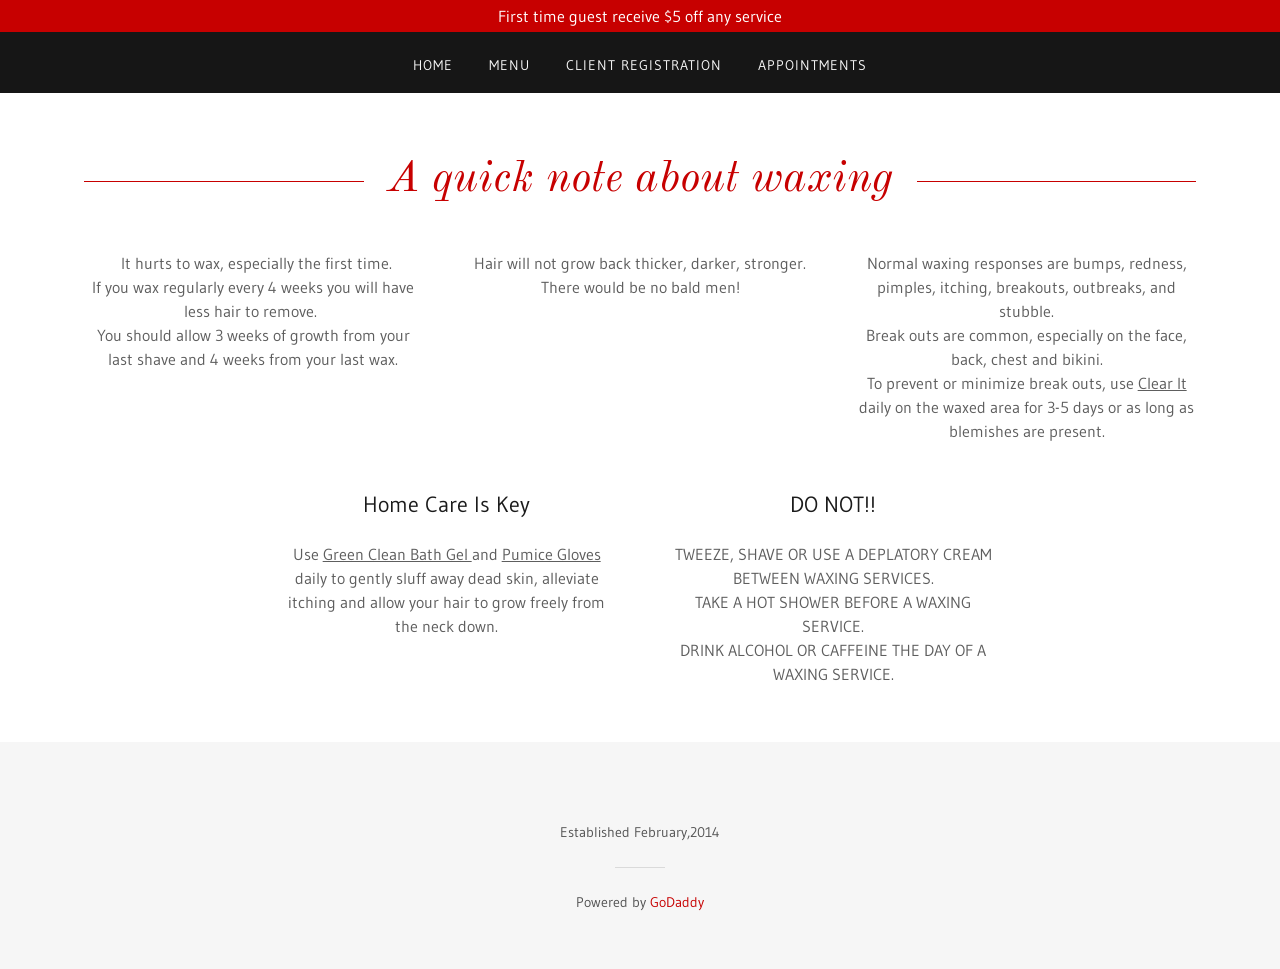Are there specific benefits highlighted in the image for regular waxing? Yes, the image highlights that regular waxing, specifically every 4 weeks, results in having less hair to remove each time. This can lead to a smoother result and potentially less discomfort during each session. It also implies that consistent waxing can lead to more manageable hair growth patterns and possibly thinner hair regrowth over time. 